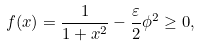Convert formula to latex. <formula><loc_0><loc_0><loc_500><loc_500>f ( x ) = \frac { 1 } { 1 + x ^ { 2 } } - \frac { \varepsilon } { 2 } \phi ^ { 2 } \geq 0 ,</formula> 